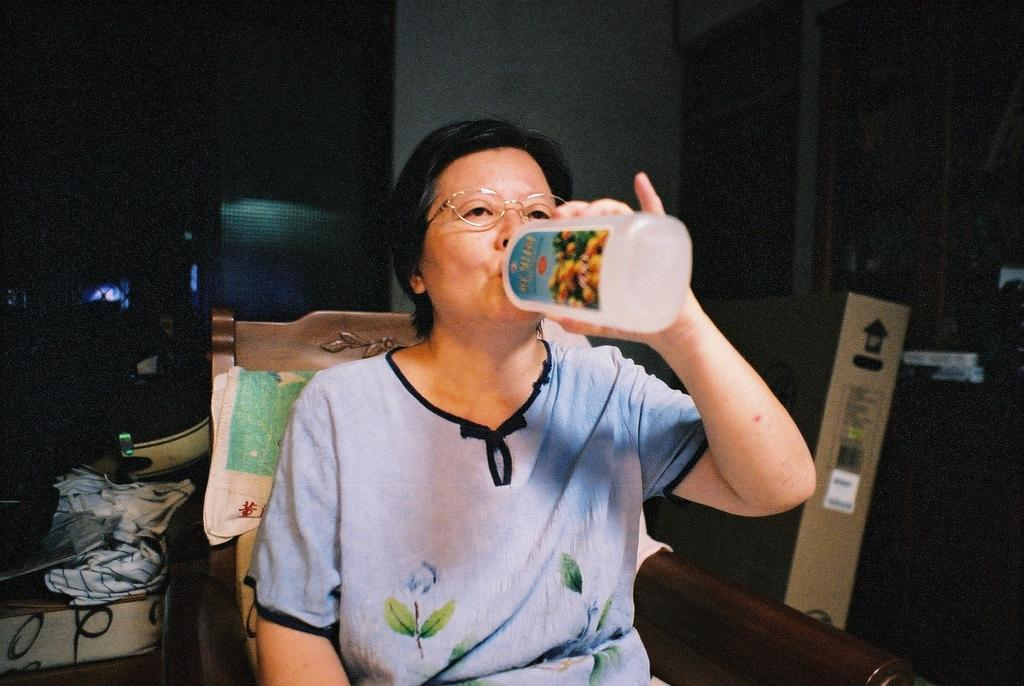What is the woman in the image doing? The woman is sitting on a chair in the image. What is the woman holding in the image? The woman is holding a bottle in the image. What type of items can be seen in the image besides the woman and the bottle? There are clothes and a cardboard box visible in the image, along with other objects. What is the color of the background in the image? The background of the image is dark. What type of flowers can be seen growing near the faucet in the image? There is no faucet or flowers present in the image. How does the sleet affect the woman's activities in the image? There is no mention of sleet in the image, and it does not affect the woman's activities. 